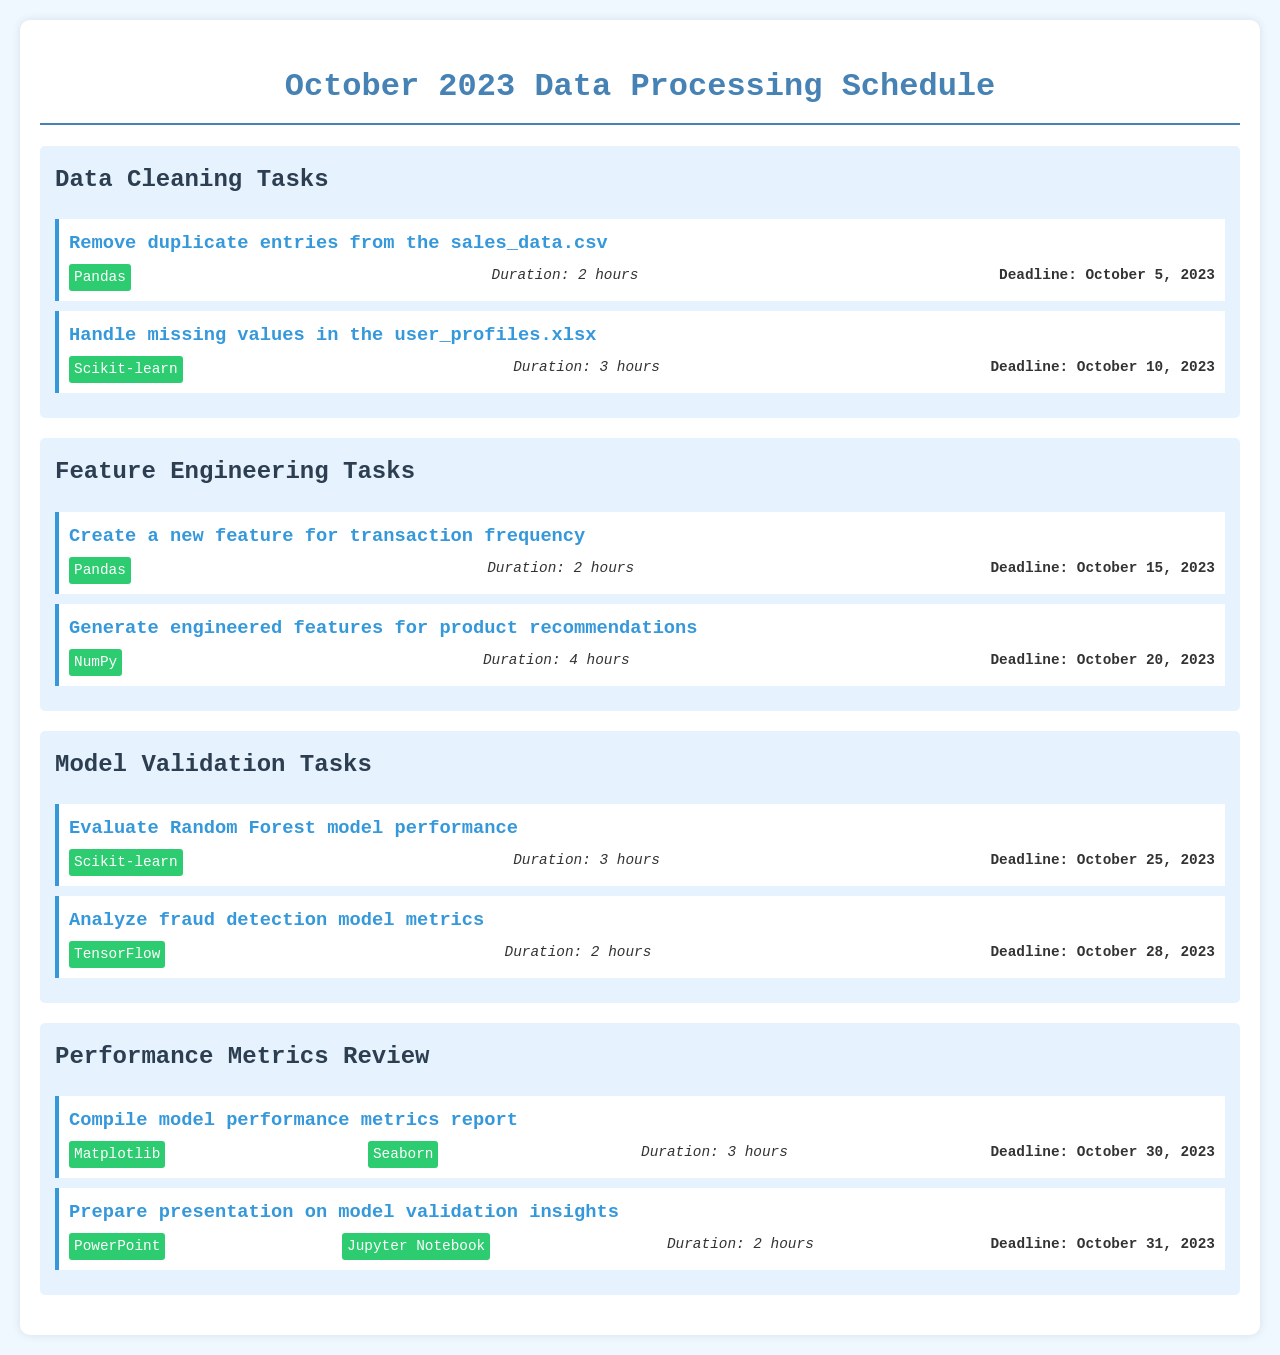What is the deadline for handling missing values? The deadline for handling missing values in user_profiles.xlsx is specified in the document.
Answer: October 10, 2023 What tool is used to create a new feature for transaction frequency? The document indicates that the tool for creating a new feature is mentioned in the task details.
Answer: Pandas How long is the duration for evaluating the Random Forest model? The duration for evaluating the model is listed in the respective task within the document.
Answer: 3 hours What is the latest deadline for performance metrics review tasks? The latest deadline among the performance metrics review tasks is noted in the schedule.
Answer: October 31, 2023 Which task is assigned a duration of 4 hours? The document lists the tasks along with their durations, indicating the task specifically assigned 4 hours.
Answer: Generate engineered features for product recommendations How many tasks are listed under Data Cleaning? The number of tasks can be counted from the section detailing Data Cleaning.
Answer: 2 tasks What is the main focus of the Model Validation Tasks section? This section outlines tasks related to validating the model's performance, as described in the task titles.
Answer: Evaluating and analyzing model performance Which two tools are used for compiling model performance metrics? The document specifies the tools to be used for this specific task within the performance metrics review section.
Answer: Matplotlib, Seaborn What is the total duration for all tasks under Feature Engineering? The total duration can be calculated by summing up the durations of individual tasks in the Feature Engineering section.
Answer: 6 hours 